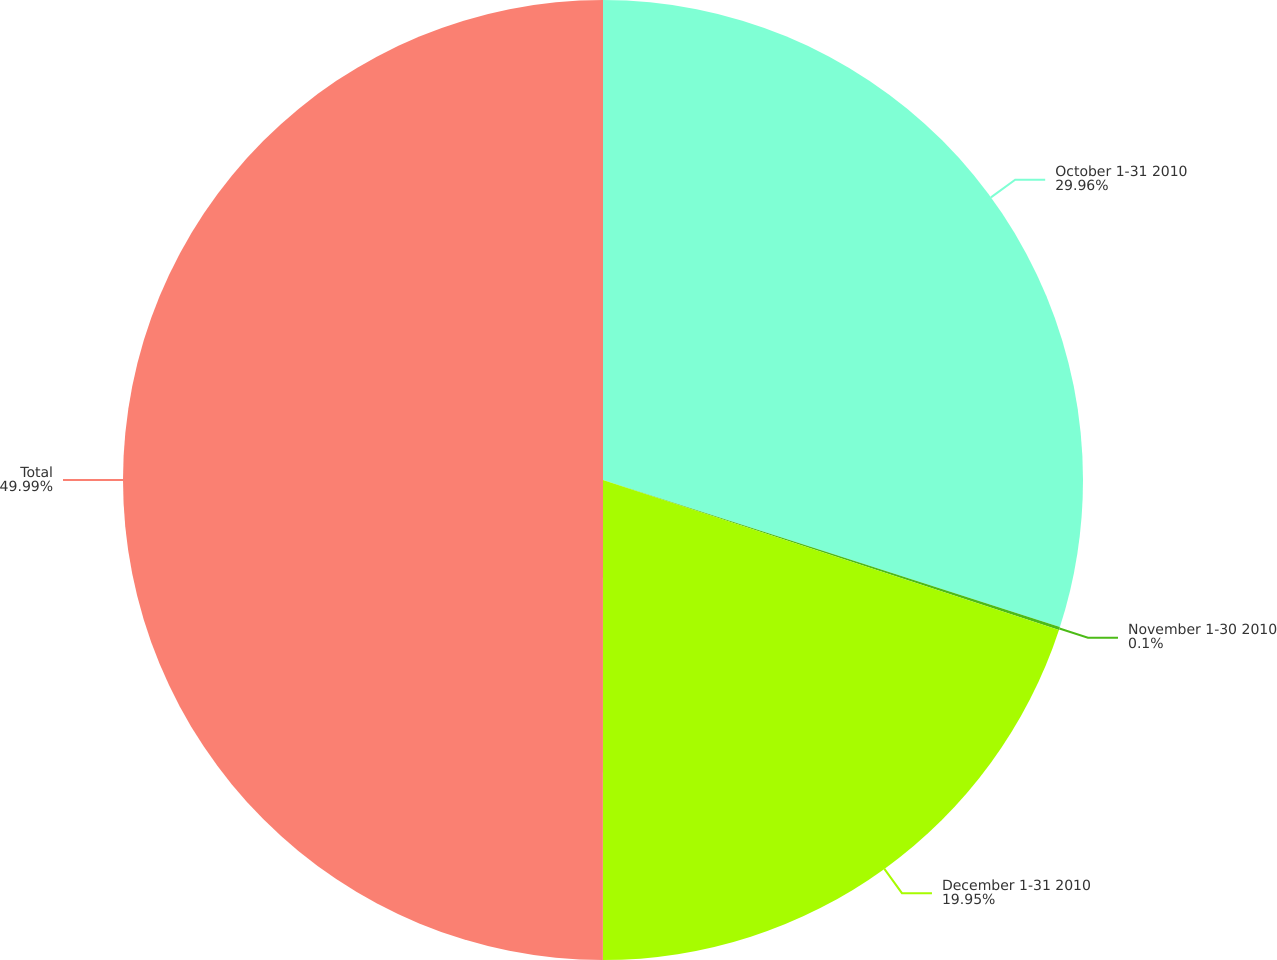Convert chart. <chart><loc_0><loc_0><loc_500><loc_500><pie_chart><fcel>October 1-31 2010<fcel>November 1-30 2010<fcel>December 1-31 2010<fcel>Total<nl><fcel>29.96%<fcel>0.1%<fcel>19.95%<fcel>50.0%<nl></chart> 